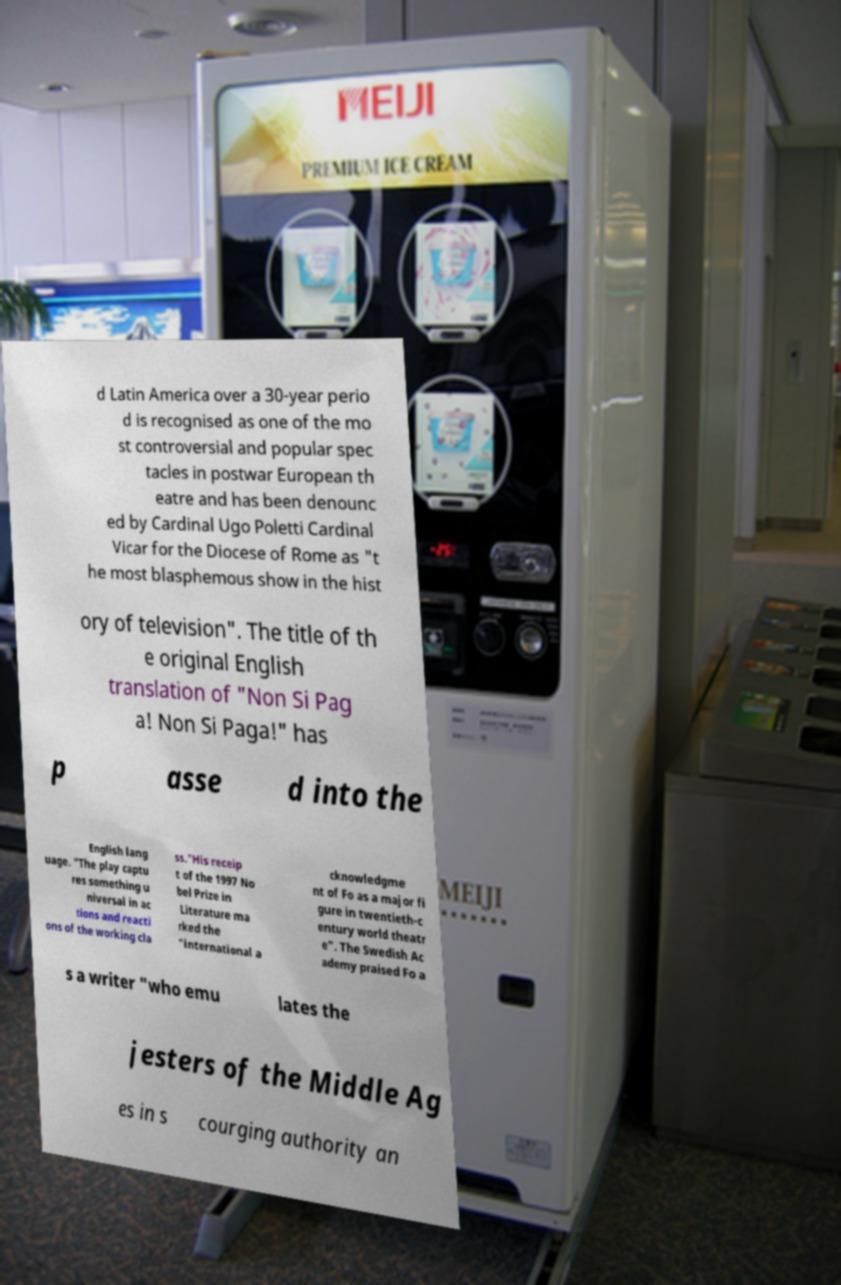For documentation purposes, I need the text within this image transcribed. Could you provide that? d Latin America over a 30-year perio d is recognised as one of the mo st controversial and popular spec tacles in postwar European th eatre and has been denounc ed by Cardinal Ugo Poletti Cardinal Vicar for the Diocese of Rome as "t he most blasphemous show in the hist ory of television". The title of th e original English translation of "Non Si Pag a! Non Si Paga!" has p asse d into the English lang uage. "The play captu res something u niversal in ac tions and reacti ons of the working cla ss."His receip t of the 1997 No bel Prize in Literature ma rked the "international a cknowledgme nt of Fo as a major fi gure in twentieth-c entury world theatr e". The Swedish Ac ademy praised Fo a s a writer "who emu lates the jesters of the Middle Ag es in s courging authority an 